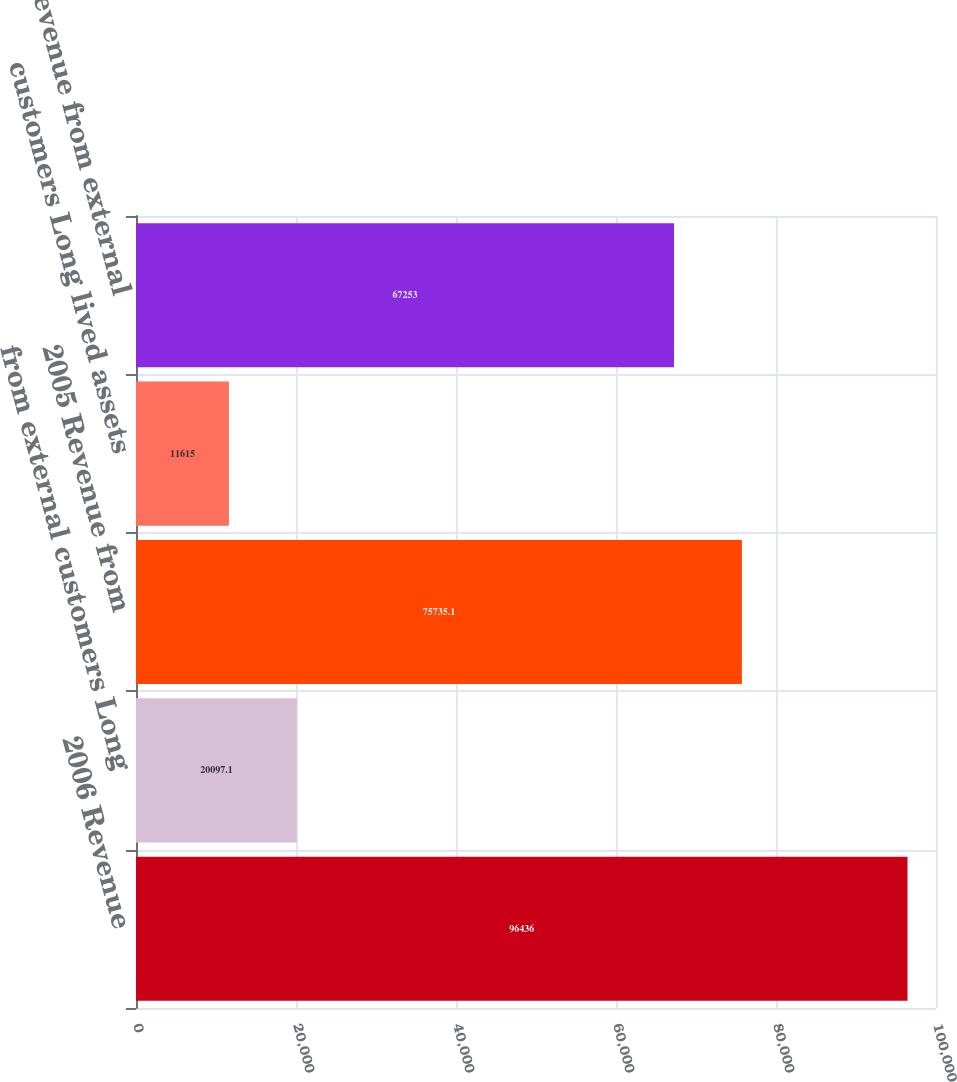Convert chart to OTSL. <chart><loc_0><loc_0><loc_500><loc_500><bar_chart><fcel>2006 Revenue<fcel>from external customers Long<fcel>2005 Revenue from<fcel>customers Long lived assets<fcel>2004 Revenue from external<nl><fcel>96436<fcel>20097.1<fcel>75735.1<fcel>11615<fcel>67253<nl></chart> 